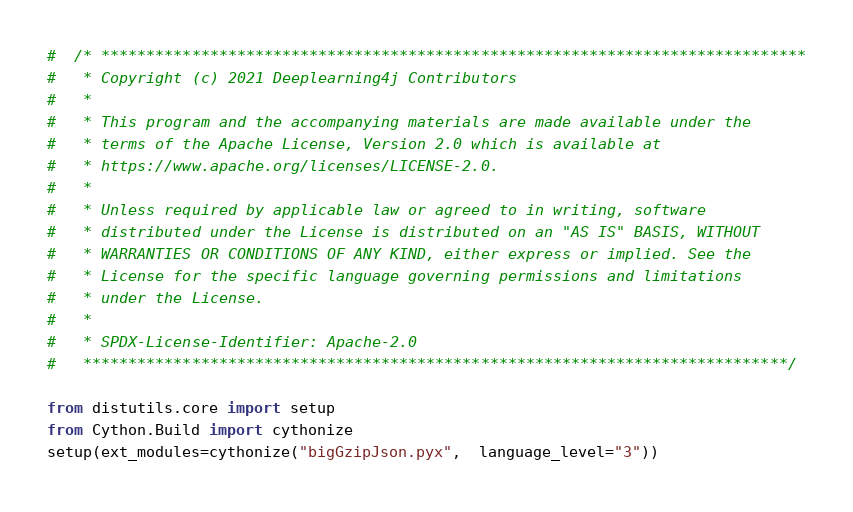Convert code to text. <code><loc_0><loc_0><loc_500><loc_500><_Python_>#  /* ******************************************************************************
#   * Copyright (c) 2021 Deeplearning4j Contributors
#   *
#   * This program and the accompanying materials are made available under the
#   * terms of the Apache License, Version 2.0 which is available at
#   * https://www.apache.org/licenses/LICENSE-2.0.
#   *
#   * Unless required by applicable law or agreed to in writing, software
#   * distributed under the License is distributed on an "AS IS" BASIS, WITHOUT
#   * WARRANTIES OR CONDITIONS OF ANY KIND, either express or implied. See the
#   * License for the specific language governing permissions and limitations
#   * under the License.
#   *
#   * SPDX-License-Identifier: Apache-2.0
#   ******************************************************************************/

from distutils.core import setup
from Cython.Build import cythonize
setup(ext_modules=cythonize("bigGzipJson.pyx",  language_level="3"))
</code> 